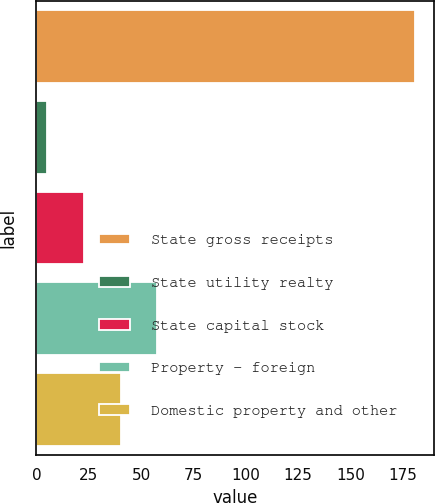Convert chart. <chart><loc_0><loc_0><loc_500><loc_500><bar_chart><fcel>State gross receipts<fcel>State utility realty<fcel>State capital stock<fcel>Property - foreign<fcel>Domestic property and other<nl><fcel>181<fcel>5<fcel>22.6<fcel>57.8<fcel>40.2<nl></chart> 